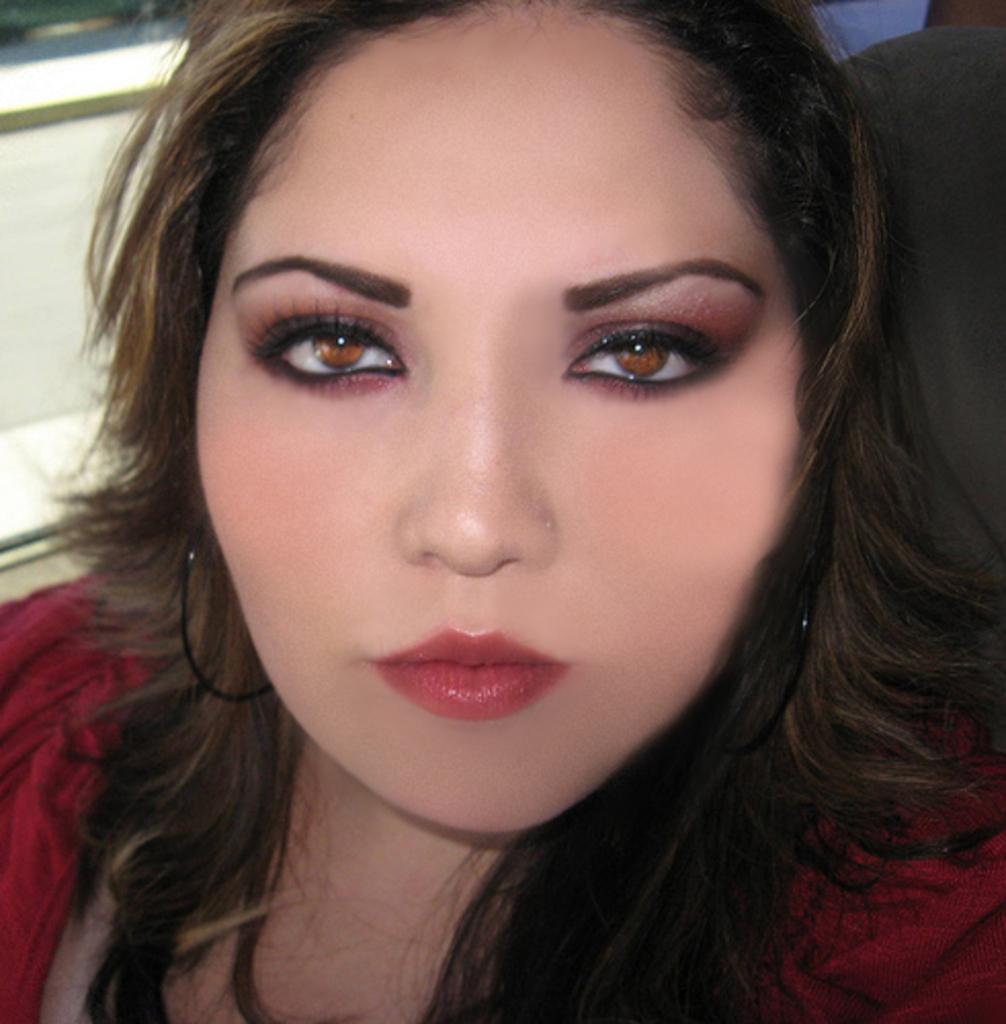In one or two sentences, can you explain what this image depicts? In this picture, we see the woman is wearing the maroon jacket. She is posing for the photo. Behind her, we see a black chair. On the left side, we see a wall in white color. 